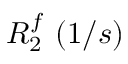Convert formula to latex. <formula><loc_0><loc_0><loc_500><loc_500>R _ { 2 } ^ { f } ( 1 / s )</formula> 